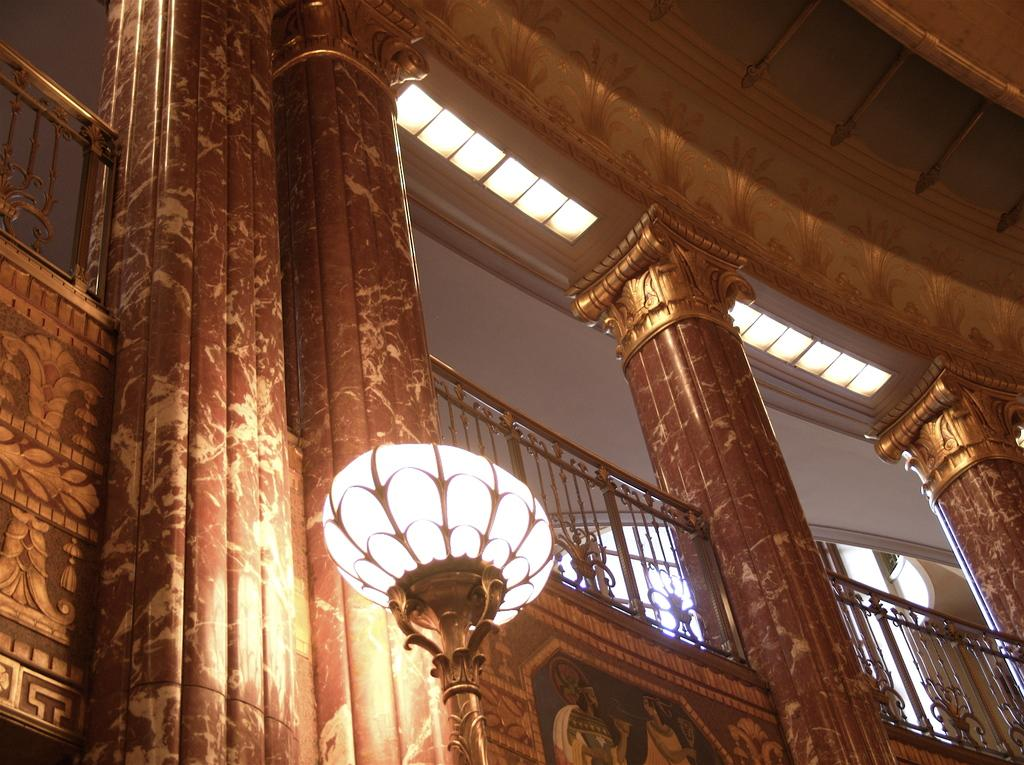What architectural features can be seen in the image? There are pillars in the image. What can be observed on the walls in the image? There is a design on the walls in the image. What type of structure is present in the image? There is a light pole in the image. What part of the building is visible in the background of the image? The ceiling is visible in the background of the image. What safety feature is present in the image? There is a railing in the image. How many eggs are being used to decorate the railing in the image? There are no eggs present in the image; the railing is not decorated with eggs. 